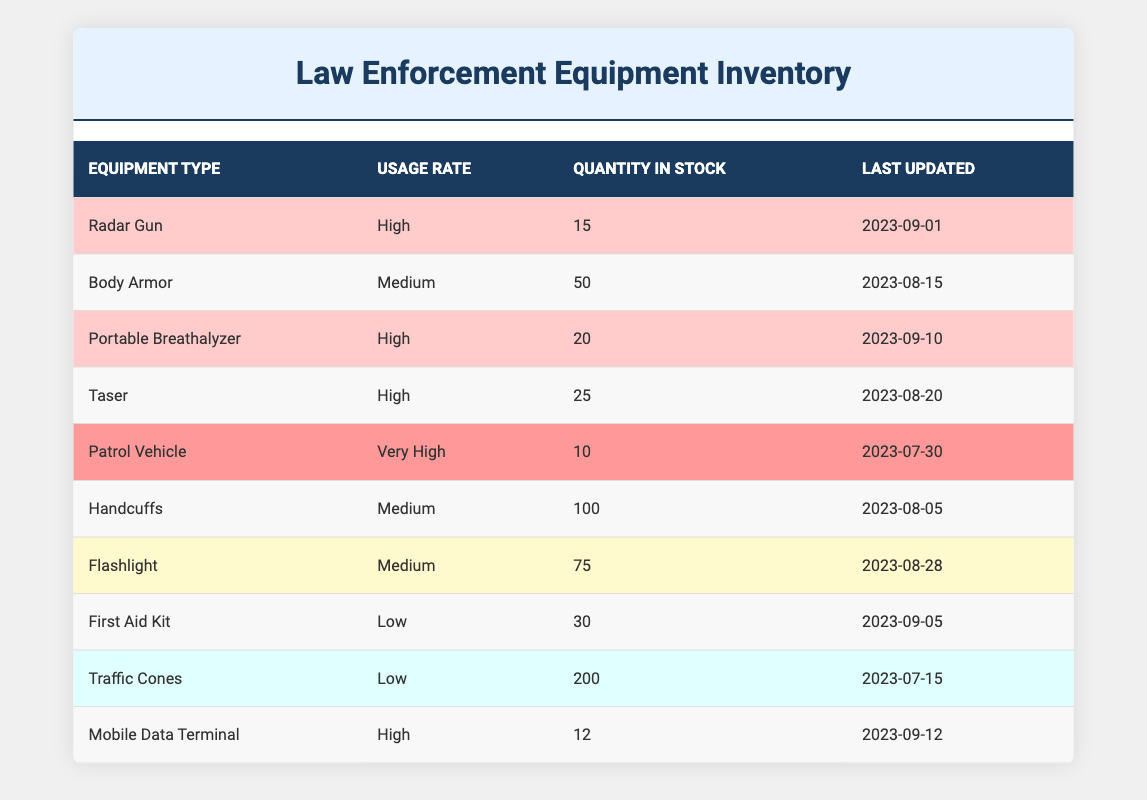What is the usage rate of Body Armor? The table shows that the usage rate of Body Armor is listed directly in the corresponding row under the Usage Rate column.
Answer: Medium How many Portable Breathalyzers are in stock? The quantity in stock for Portable Breathalyzers is directly provided in the corresponding row under the Quantity in Stock column.
Answer: 20 What is the total quantity of Equipment with a High usage rate? We need to identify all equipment types with a High usage rate: Radar Gun (15), Portable Breathalyzer (20), Taser (25), and Mobile Data Terminal (12). Adding these gives 15 + 20 + 25 + 12 = 72.
Answer: 72 Are there more Traffic Cones or Handcuffs in stock? The table states that there are 200 Traffic Cones and 100 Handcuffs in stock. Since 200 is greater than 100, we conclude that there are more Traffic Cones.
Answer: Yes What equipment is the last updated on 2023-09-10? The table indicates that the item updated on 2023-09-10 is the Portable Breathalyzer. We find this by scanning the Last Updated column for the corresponding date.
Answer: Portable Breathalyzer Which equipment type has the highest usage rate? The highest usage rate listed is "Very High," and the equipment associated with this is the Patrol Vehicle. This is determined by reviewing the Usage Rate column.
Answer: Patrol Vehicle What is the total quantity of all equipment with a Medium usage rate? We identify all equipment types with a Medium usage rate: Body Armor (50), Handcuffs (100), and Flashlight (75). We then sum these quantities: 50 + 100 + 75 = 225.
Answer: 225 Is the quantity in stock for Taser greater than or equal to that of Mobile Data Terminal? The Taser has a quantity of 25, while the Mobile Data Terminal has a stock of 12. Since 25 is greater than 12, we conclude that the quantity of Taser is greater.
Answer: Yes How many equipment types have a Low usage rate? From the table, we see that two types, First Aid Kit and Traffic Cones, are categorized with a Low usage rate. Counting these gives us a total of 2.
Answer: 2 